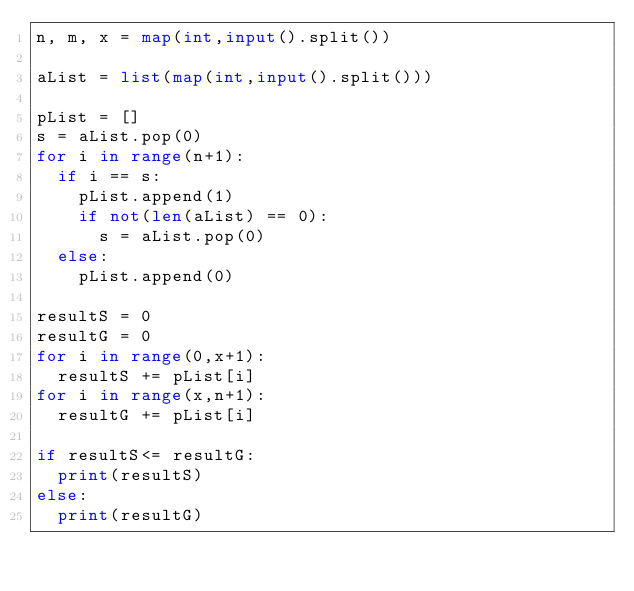Convert code to text. <code><loc_0><loc_0><loc_500><loc_500><_Python_>n, m, x = map(int,input().split())

aList = list(map(int,input().split()))

pList = []
s = aList.pop(0)
for i in range(n+1):
  if i == s:
    pList.append(1)
    if not(len(aList) == 0):
      s = aList.pop(0)
  else:
    pList.append(0)

resultS = 0
resultG = 0
for i in range(0,x+1):
  resultS += pList[i]
for i in range(x,n+1):
  resultG += pList[i]

if resultS<= resultG:
  print(resultS)
else:
  print(resultG)
  </code> 